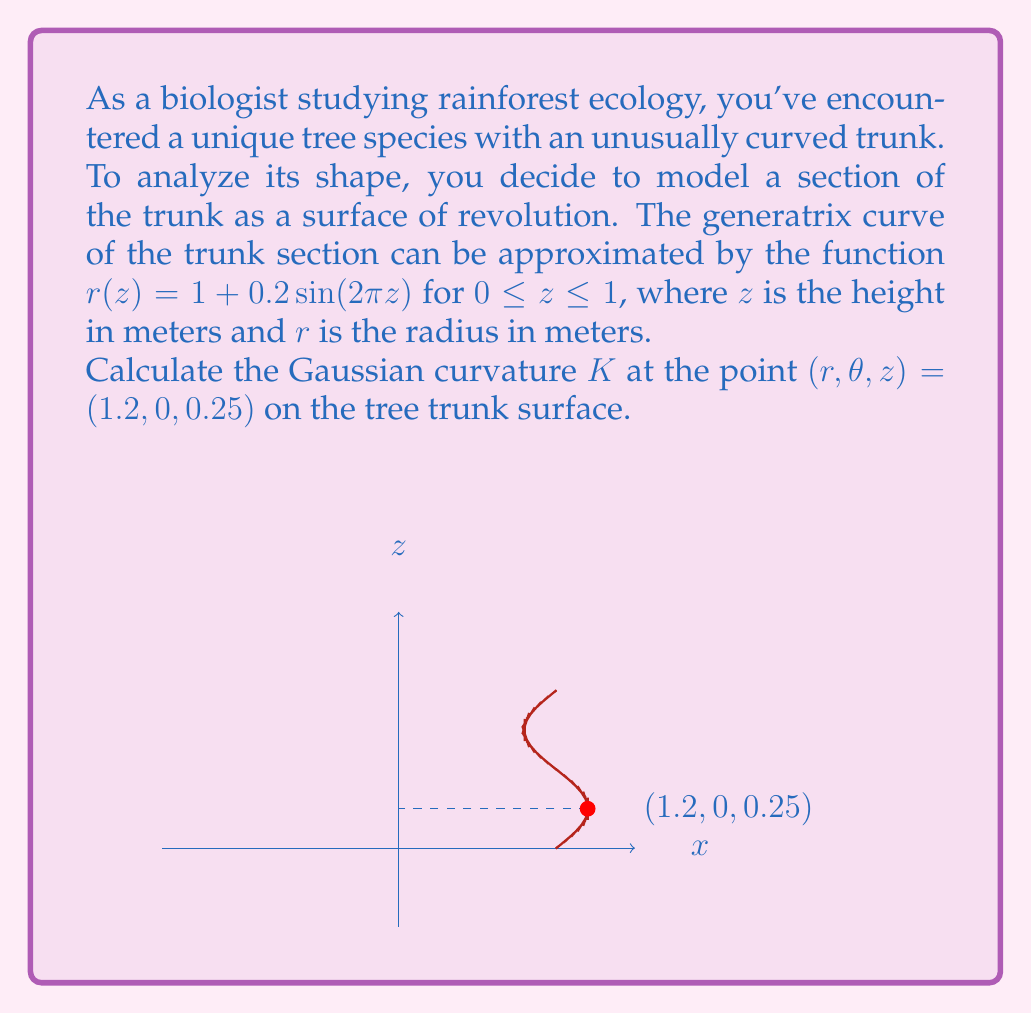Can you solve this math problem? Let's approach this step-by-step:

1) For a surface of revolution, the Gaussian curvature $K$ is given by:

   $$K = -\frac{r''(z)}{r(z)[1 + (r'(z))^2]^{3/2}}$$

   where $r(z)$ is the generatrix function and $r'(z)$ and $r''(z)$ are its first and second derivatives.

2) We're given $r(z) = 1 + 0.2\sin(2\pi z)$. Let's calculate $r'(z)$ and $r''(z)$:

   $$r'(z) = 0.2 \cdot 2\pi \cos(2\pi z) = 0.4\pi \cos(2\pi z)$$
   $$r''(z) = 0.4\pi \cdot -2\pi \sin(2\pi z) = -0.8\pi^2 \sin(2\pi z)$$

3) At $z = 0.25$, we need to calculate:
   
   $r(0.25) = 1 + 0.2\sin(2\pi \cdot 0.25) = 1 + 0.2 = 1.2$
   
   $r'(0.25) = 0.4\pi \cos(2\pi \cdot 0.25) = 0.4\pi \cos(\pi/2) = 0$
   
   $r''(0.25) = -0.8\pi^2 \sin(2\pi \cdot 0.25) = -0.8\pi^2 \sin(\pi/2) = -0.8\pi^2$

4) Now, let's substitute these values into the Gaussian curvature formula:

   $$K = -\frac{r''(z)}{r(z)[1 + (r'(z))^2]^{3/2}}$$

   $$K = -\frac{-0.8\pi^2}{1.2[1 + (0)^2]^{3/2}}$$

   $$K = \frac{0.8\pi^2}{1.2} = \frac{2\pi^2}{3}$$

Therefore, the Gaussian curvature at the point $(1.2, 0, 0.25)$ is $\frac{2\pi^2}{3}$.
Answer: $\frac{2\pi^2}{3}$ 